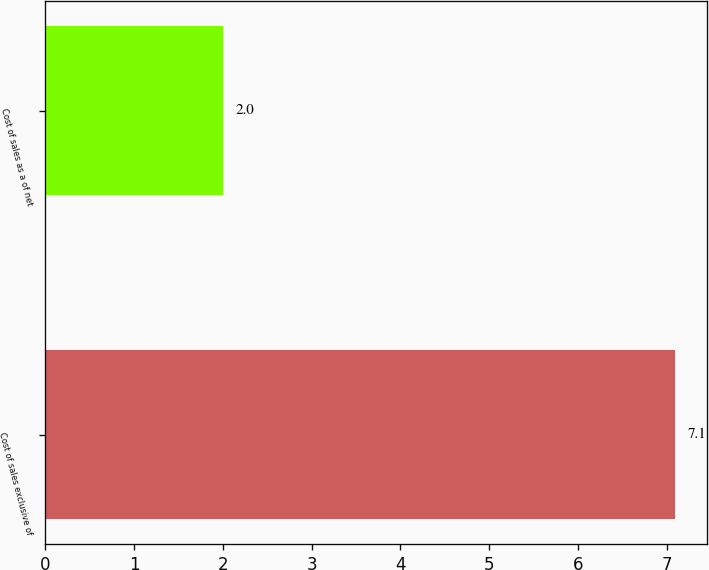Convert chart. <chart><loc_0><loc_0><loc_500><loc_500><bar_chart><fcel>Cost of sales exclusive of<fcel>Cost of sales as a of net<nl><fcel>7.1<fcel>2<nl></chart> 